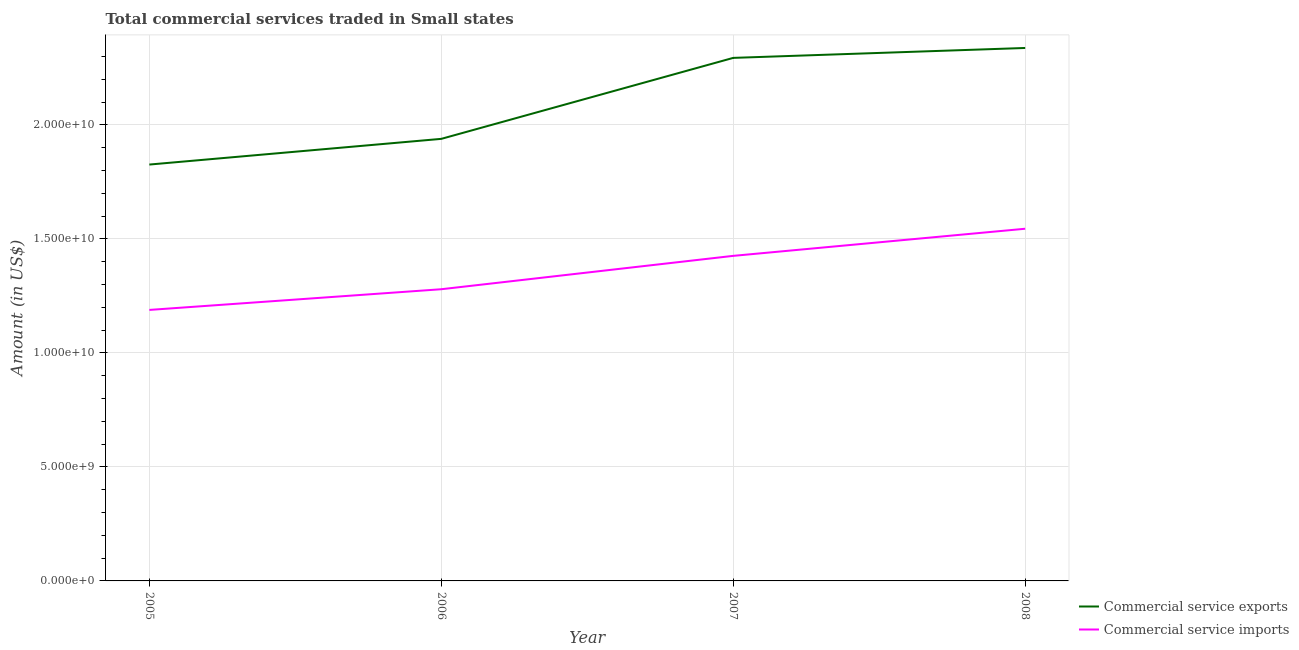Does the line corresponding to amount of commercial service exports intersect with the line corresponding to amount of commercial service imports?
Make the answer very short. No. Is the number of lines equal to the number of legend labels?
Give a very brief answer. Yes. What is the amount of commercial service exports in 2008?
Your answer should be compact. 2.34e+1. Across all years, what is the maximum amount of commercial service imports?
Provide a succinct answer. 1.54e+1. Across all years, what is the minimum amount of commercial service exports?
Provide a short and direct response. 1.83e+1. In which year was the amount of commercial service imports maximum?
Provide a short and direct response. 2008. In which year was the amount of commercial service imports minimum?
Offer a terse response. 2005. What is the total amount of commercial service exports in the graph?
Offer a terse response. 8.40e+1. What is the difference between the amount of commercial service exports in 2005 and that in 2007?
Your answer should be very brief. -4.68e+09. What is the difference between the amount of commercial service imports in 2007 and the amount of commercial service exports in 2008?
Provide a succinct answer. -9.12e+09. What is the average amount of commercial service exports per year?
Your response must be concise. 2.10e+1. In the year 2006, what is the difference between the amount of commercial service exports and amount of commercial service imports?
Provide a succinct answer. 6.60e+09. In how many years, is the amount of commercial service imports greater than 17000000000 US$?
Keep it short and to the point. 0. What is the ratio of the amount of commercial service exports in 2005 to that in 2006?
Your answer should be compact. 0.94. Is the amount of commercial service imports in 2005 less than that in 2008?
Your answer should be compact. Yes. What is the difference between the highest and the second highest amount of commercial service imports?
Offer a terse response. 1.19e+09. What is the difference between the highest and the lowest amount of commercial service imports?
Offer a terse response. 3.56e+09. In how many years, is the amount of commercial service exports greater than the average amount of commercial service exports taken over all years?
Make the answer very short. 2. Is the sum of the amount of commercial service imports in 2006 and 2007 greater than the maximum amount of commercial service exports across all years?
Offer a very short reply. Yes. Does the amount of commercial service imports monotonically increase over the years?
Provide a short and direct response. Yes. Is the amount of commercial service imports strictly greater than the amount of commercial service exports over the years?
Your answer should be very brief. No. Are the values on the major ticks of Y-axis written in scientific E-notation?
Make the answer very short. Yes. Where does the legend appear in the graph?
Provide a short and direct response. Bottom right. How many legend labels are there?
Offer a terse response. 2. How are the legend labels stacked?
Make the answer very short. Vertical. What is the title of the graph?
Provide a short and direct response. Total commercial services traded in Small states. What is the label or title of the X-axis?
Offer a very short reply. Year. What is the label or title of the Y-axis?
Provide a short and direct response. Amount (in US$). What is the Amount (in US$) in Commercial service exports in 2005?
Ensure brevity in your answer.  1.83e+1. What is the Amount (in US$) of Commercial service imports in 2005?
Ensure brevity in your answer.  1.19e+1. What is the Amount (in US$) in Commercial service exports in 2006?
Offer a terse response. 1.94e+1. What is the Amount (in US$) in Commercial service imports in 2006?
Provide a short and direct response. 1.28e+1. What is the Amount (in US$) in Commercial service exports in 2007?
Keep it short and to the point. 2.29e+1. What is the Amount (in US$) in Commercial service imports in 2007?
Give a very brief answer. 1.43e+1. What is the Amount (in US$) of Commercial service exports in 2008?
Provide a short and direct response. 2.34e+1. What is the Amount (in US$) in Commercial service imports in 2008?
Offer a terse response. 1.54e+1. Across all years, what is the maximum Amount (in US$) of Commercial service exports?
Your answer should be compact. 2.34e+1. Across all years, what is the maximum Amount (in US$) of Commercial service imports?
Your response must be concise. 1.54e+1. Across all years, what is the minimum Amount (in US$) in Commercial service exports?
Provide a short and direct response. 1.83e+1. Across all years, what is the minimum Amount (in US$) of Commercial service imports?
Offer a terse response. 1.19e+1. What is the total Amount (in US$) of Commercial service exports in the graph?
Offer a very short reply. 8.40e+1. What is the total Amount (in US$) in Commercial service imports in the graph?
Make the answer very short. 5.44e+1. What is the difference between the Amount (in US$) in Commercial service exports in 2005 and that in 2006?
Your response must be concise. -1.13e+09. What is the difference between the Amount (in US$) in Commercial service imports in 2005 and that in 2006?
Offer a very short reply. -9.08e+08. What is the difference between the Amount (in US$) in Commercial service exports in 2005 and that in 2007?
Your answer should be compact. -4.68e+09. What is the difference between the Amount (in US$) of Commercial service imports in 2005 and that in 2007?
Your answer should be compact. -2.37e+09. What is the difference between the Amount (in US$) of Commercial service exports in 2005 and that in 2008?
Provide a short and direct response. -5.11e+09. What is the difference between the Amount (in US$) in Commercial service imports in 2005 and that in 2008?
Provide a short and direct response. -3.56e+09. What is the difference between the Amount (in US$) in Commercial service exports in 2006 and that in 2007?
Your response must be concise. -3.55e+09. What is the difference between the Amount (in US$) in Commercial service imports in 2006 and that in 2007?
Your answer should be very brief. -1.46e+09. What is the difference between the Amount (in US$) of Commercial service exports in 2006 and that in 2008?
Give a very brief answer. -3.99e+09. What is the difference between the Amount (in US$) in Commercial service imports in 2006 and that in 2008?
Provide a short and direct response. -2.65e+09. What is the difference between the Amount (in US$) of Commercial service exports in 2007 and that in 2008?
Your answer should be compact. -4.35e+08. What is the difference between the Amount (in US$) of Commercial service imports in 2007 and that in 2008?
Make the answer very short. -1.19e+09. What is the difference between the Amount (in US$) of Commercial service exports in 2005 and the Amount (in US$) of Commercial service imports in 2006?
Your answer should be compact. 5.47e+09. What is the difference between the Amount (in US$) in Commercial service exports in 2005 and the Amount (in US$) in Commercial service imports in 2007?
Ensure brevity in your answer.  4.00e+09. What is the difference between the Amount (in US$) in Commercial service exports in 2005 and the Amount (in US$) in Commercial service imports in 2008?
Give a very brief answer. 2.82e+09. What is the difference between the Amount (in US$) in Commercial service exports in 2006 and the Amount (in US$) in Commercial service imports in 2007?
Your answer should be compact. 5.13e+09. What is the difference between the Amount (in US$) in Commercial service exports in 2006 and the Amount (in US$) in Commercial service imports in 2008?
Give a very brief answer. 3.94e+09. What is the difference between the Amount (in US$) of Commercial service exports in 2007 and the Amount (in US$) of Commercial service imports in 2008?
Your answer should be very brief. 7.49e+09. What is the average Amount (in US$) of Commercial service exports per year?
Ensure brevity in your answer.  2.10e+1. What is the average Amount (in US$) in Commercial service imports per year?
Keep it short and to the point. 1.36e+1. In the year 2005, what is the difference between the Amount (in US$) in Commercial service exports and Amount (in US$) in Commercial service imports?
Provide a succinct answer. 6.38e+09. In the year 2006, what is the difference between the Amount (in US$) in Commercial service exports and Amount (in US$) in Commercial service imports?
Provide a short and direct response. 6.60e+09. In the year 2007, what is the difference between the Amount (in US$) of Commercial service exports and Amount (in US$) of Commercial service imports?
Give a very brief answer. 8.68e+09. In the year 2008, what is the difference between the Amount (in US$) of Commercial service exports and Amount (in US$) of Commercial service imports?
Give a very brief answer. 7.93e+09. What is the ratio of the Amount (in US$) of Commercial service exports in 2005 to that in 2006?
Make the answer very short. 0.94. What is the ratio of the Amount (in US$) of Commercial service imports in 2005 to that in 2006?
Provide a short and direct response. 0.93. What is the ratio of the Amount (in US$) of Commercial service exports in 2005 to that in 2007?
Provide a short and direct response. 0.8. What is the ratio of the Amount (in US$) of Commercial service imports in 2005 to that in 2007?
Provide a short and direct response. 0.83. What is the ratio of the Amount (in US$) in Commercial service exports in 2005 to that in 2008?
Give a very brief answer. 0.78. What is the ratio of the Amount (in US$) of Commercial service imports in 2005 to that in 2008?
Provide a short and direct response. 0.77. What is the ratio of the Amount (in US$) of Commercial service exports in 2006 to that in 2007?
Your answer should be compact. 0.85. What is the ratio of the Amount (in US$) in Commercial service imports in 2006 to that in 2007?
Give a very brief answer. 0.9. What is the ratio of the Amount (in US$) of Commercial service exports in 2006 to that in 2008?
Provide a succinct answer. 0.83. What is the ratio of the Amount (in US$) in Commercial service imports in 2006 to that in 2008?
Make the answer very short. 0.83. What is the ratio of the Amount (in US$) of Commercial service exports in 2007 to that in 2008?
Offer a terse response. 0.98. What is the ratio of the Amount (in US$) of Commercial service imports in 2007 to that in 2008?
Keep it short and to the point. 0.92. What is the difference between the highest and the second highest Amount (in US$) in Commercial service exports?
Ensure brevity in your answer.  4.35e+08. What is the difference between the highest and the second highest Amount (in US$) of Commercial service imports?
Your answer should be compact. 1.19e+09. What is the difference between the highest and the lowest Amount (in US$) of Commercial service exports?
Provide a short and direct response. 5.11e+09. What is the difference between the highest and the lowest Amount (in US$) of Commercial service imports?
Provide a succinct answer. 3.56e+09. 